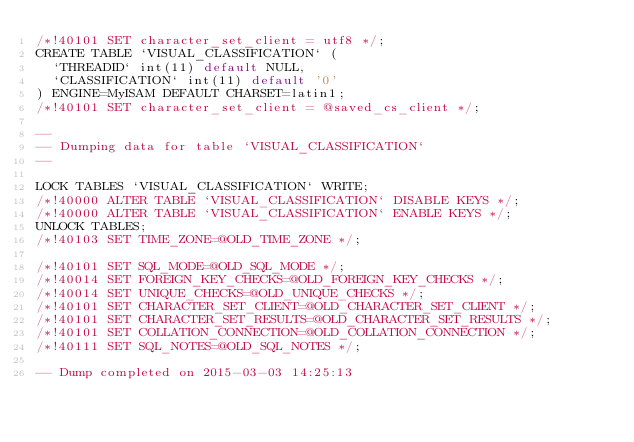<code> <loc_0><loc_0><loc_500><loc_500><_SQL_>/*!40101 SET character_set_client = utf8 */;
CREATE TABLE `VISUAL_CLASSIFICATION` (
  `THREADID` int(11) default NULL,
  `CLASSIFICATION` int(11) default '0'
) ENGINE=MyISAM DEFAULT CHARSET=latin1;
/*!40101 SET character_set_client = @saved_cs_client */;

--
-- Dumping data for table `VISUAL_CLASSIFICATION`
--

LOCK TABLES `VISUAL_CLASSIFICATION` WRITE;
/*!40000 ALTER TABLE `VISUAL_CLASSIFICATION` DISABLE KEYS */;
/*!40000 ALTER TABLE `VISUAL_CLASSIFICATION` ENABLE KEYS */;
UNLOCK TABLES;
/*!40103 SET TIME_ZONE=@OLD_TIME_ZONE */;

/*!40101 SET SQL_MODE=@OLD_SQL_MODE */;
/*!40014 SET FOREIGN_KEY_CHECKS=@OLD_FOREIGN_KEY_CHECKS */;
/*!40014 SET UNIQUE_CHECKS=@OLD_UNIQUE_CHECKS */;
/*!40101 SET CHARACTER_SET_CLIENT=@OLD_CHARACTER_SET_CLIENT */;
/*!40101 SET CHARACTER_SET_RESULTS=@OLD_CHARACTER_SET_RESULTS */;
/*!40101 SET COLLATION_CONNECTION=@OLD_COLLATION_CONNECTION */;
/*!40111 SET SQL_NOTES=@OLD_SQL_NOTES */;

-- Dump completed on 2015-03-03 14:25:13
</code> 